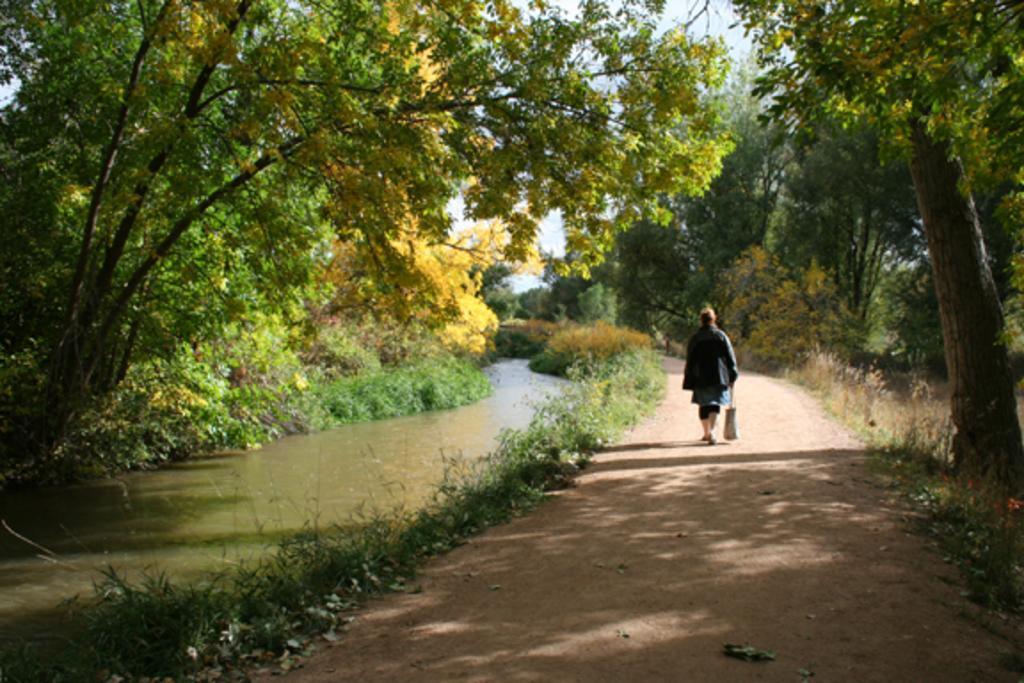Can you describe this image briefly? In this picture we can see a person on the ground and this person is holding a bag, here we can see plants, water and in the background we can see trees, sky. 